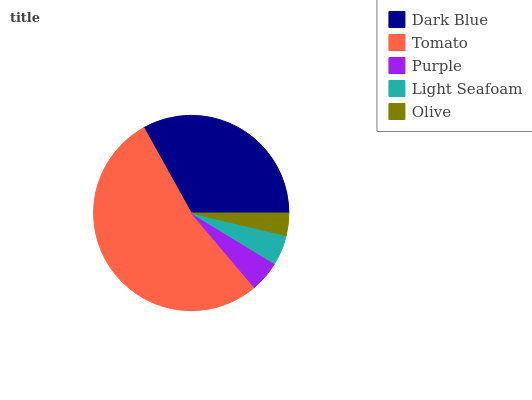Is Olive the minimum?
Answer yes or no. Yes. Is Tomato the maximum?
Answer yes or no. Yes. Is Purple the minimum?
Answer yes or no. No. Is Purple the maximum?
Answer yes or no. No. Is Tomato greater than Purple?
Answer yes or no. Yes. Is Purple less than Tomato?
Answer yes or no. Yes. Is Purple greater than Tomato?
Answer yes or no. No. Is Tomato less than Purple?
Answer yes or no. No. Is Purple the high median?
Answer yes or no. Yes. Is Purple the low median?
Answer yes or no. Yes. Is Dark Blue the high median?
Answer yes or no. No. Is Olive the low median?
Answer yes or no. No. 